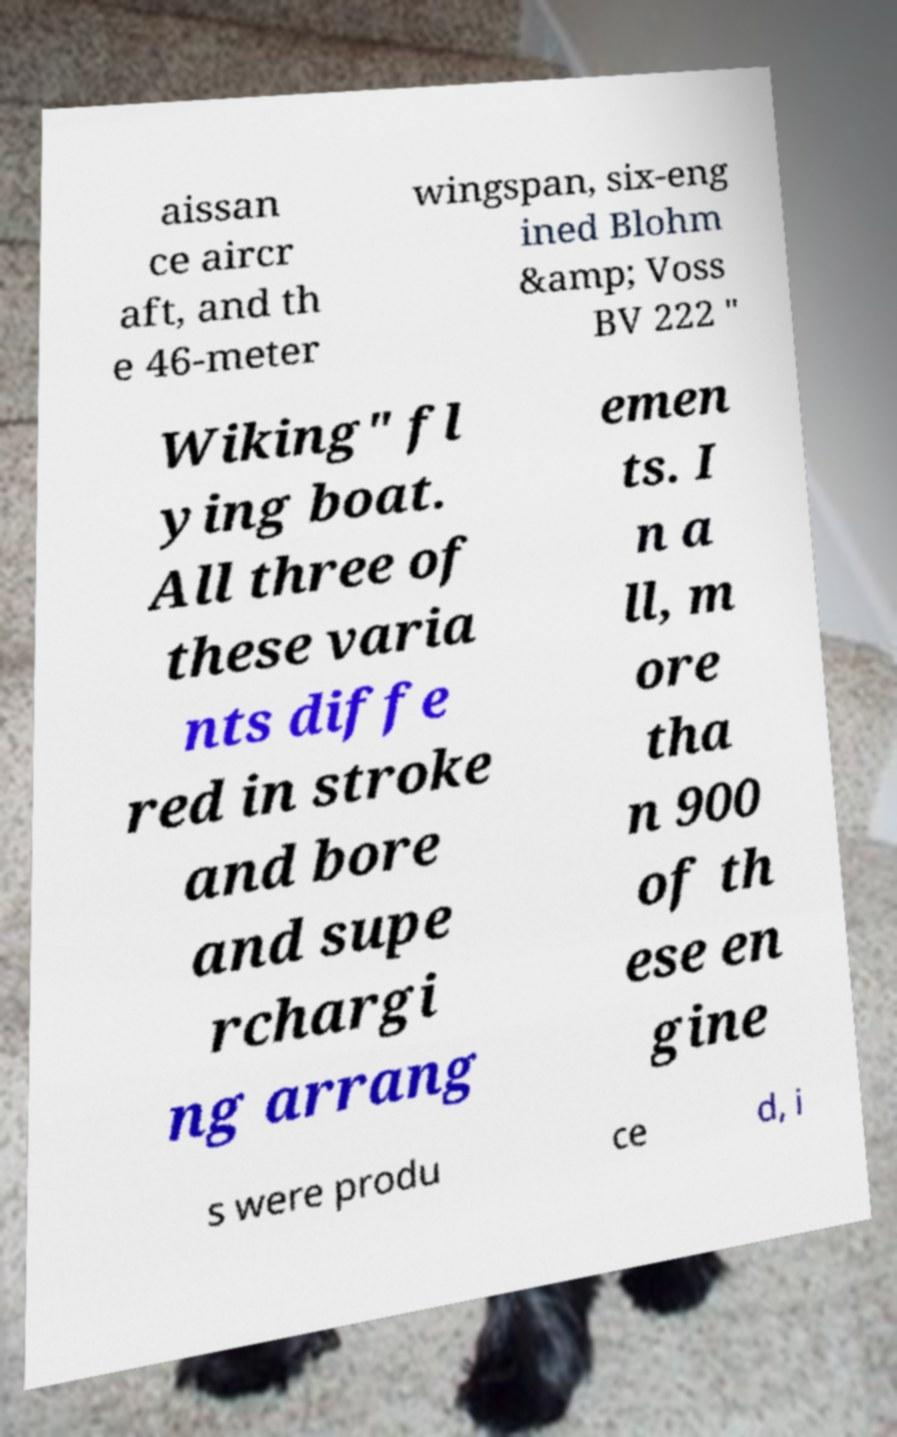Could you assist in decoding the text presented in this image and type it out clearly? aissan ce aircr aft, and th e 46-meter wingspan, six-eng ined Blohm &amp; Voss BV 222 " Wiking" fl ying boat. All three of these varia nts diffe red in stroke and bore and supe rchargi ng arrang emen ts. I n a ll, m ore tha n 900 of th ese en gine s were produ ce d, i 